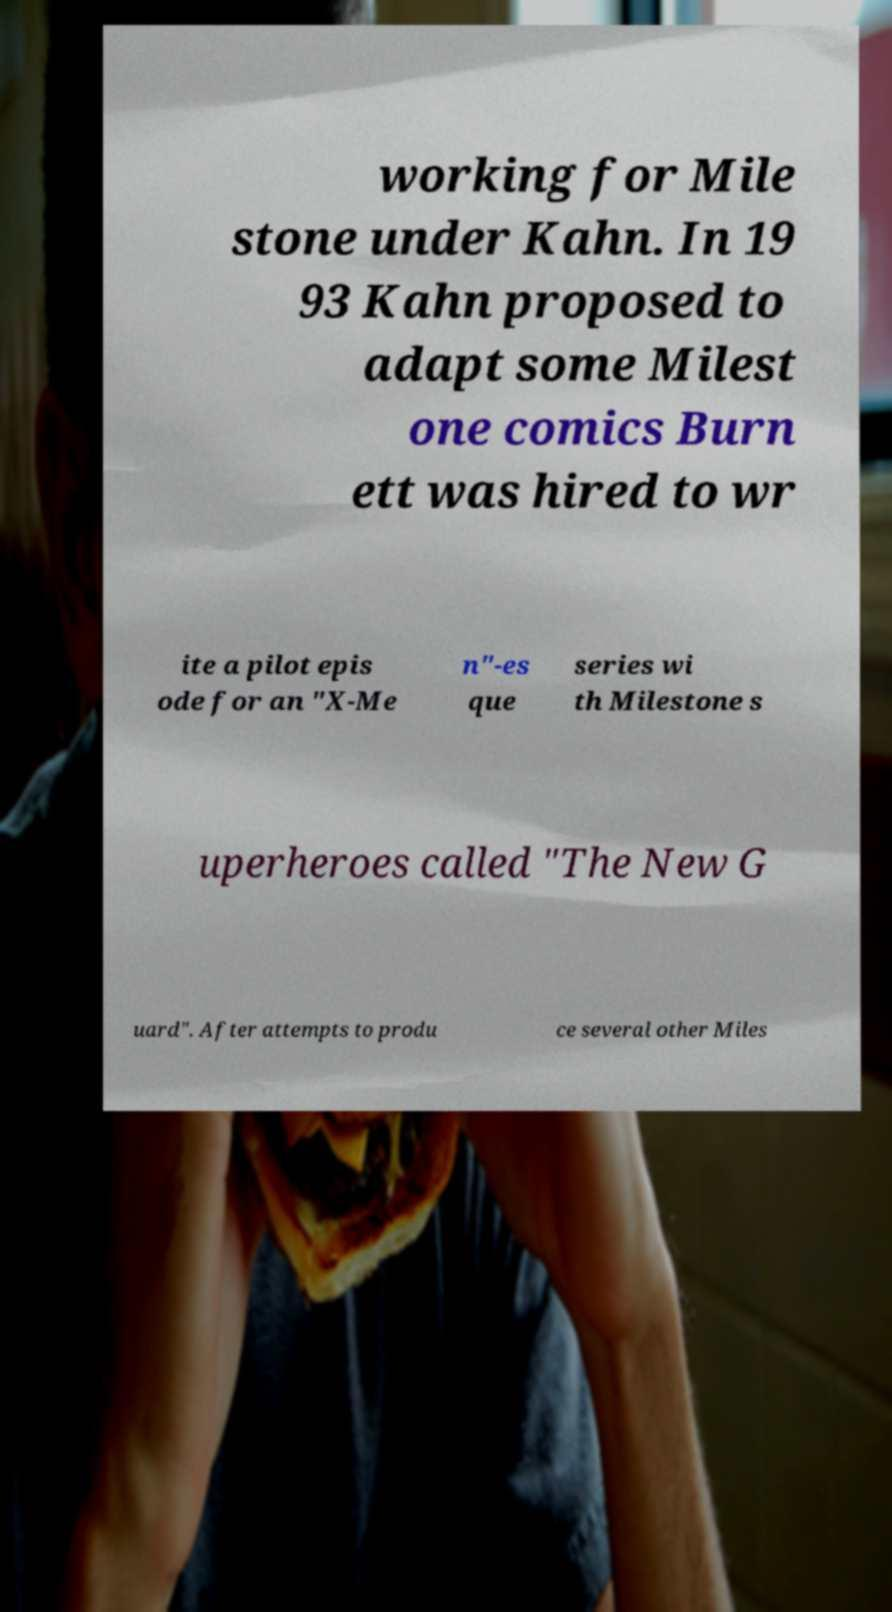Could you extract and type out the text from this image? working for Mile stone under Kahn. In 19 93 Kahn proposed to adapt some Milest one comics Burn ett was hired to wr ite a pilot epis ode for an "X-Me n"-es que series wi th Milestone s uperheroes called "The New G uard". After attempts to produ ce several other Miles 